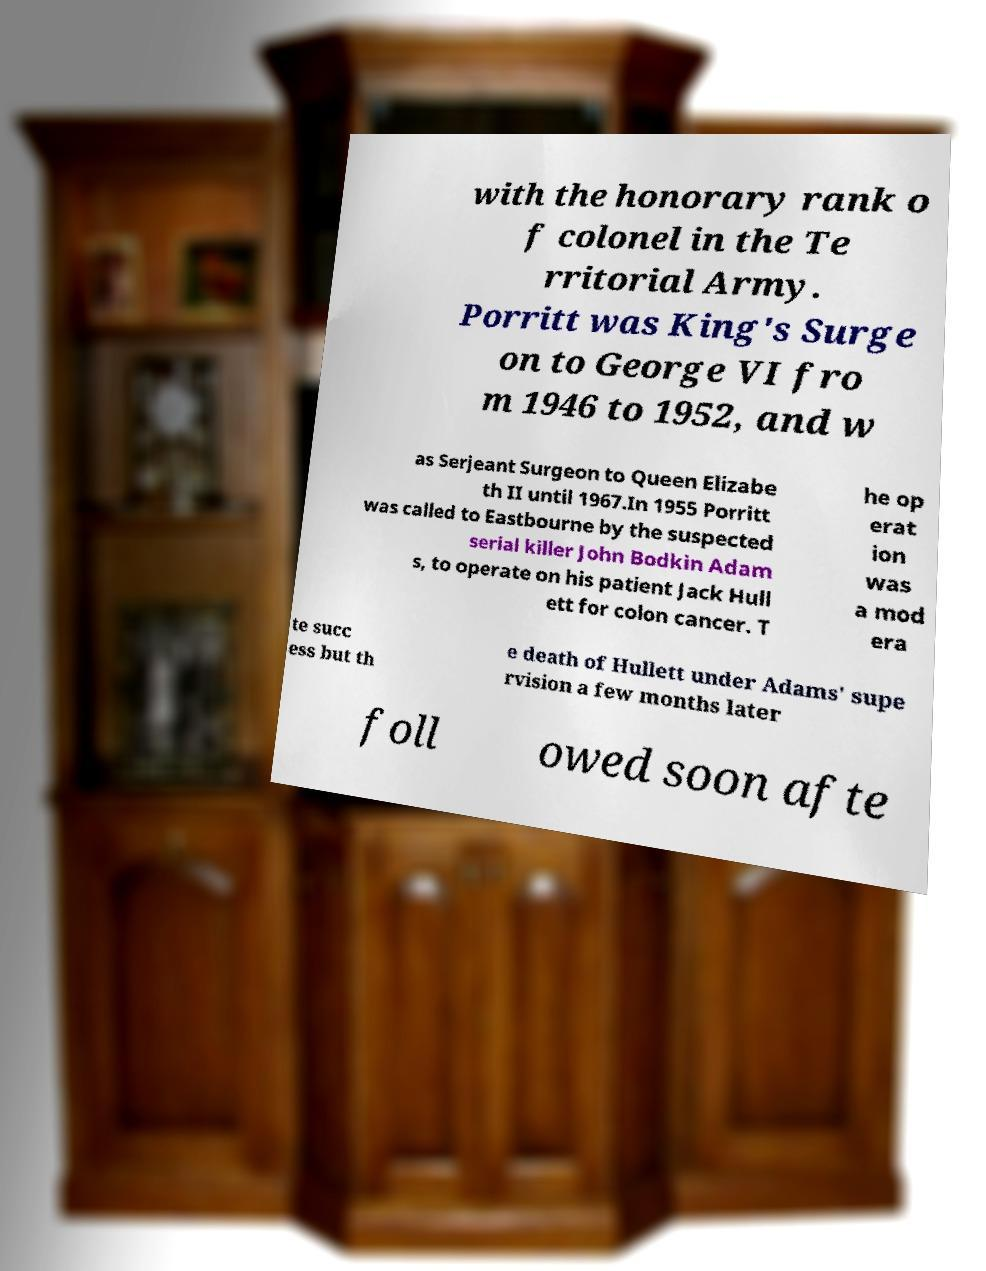Please identify and transcribe the text found in this image. with the honorary rank o f colonel in the Te rritorial Army. Porritt was King's Surge on to George VI fro m 1946 to 1952, and w as Serjeant Surgeon to Queen Elizabe th II until 1967.In 1955 Porritt was called to Eastbourne by the suspected serial killer John Bodkin Adam s, to operate on his patient Jack Hull ett for colon cancer. T he op erat ion was a mod era te succ ess but th e death of Hullett under Adams' supe rvision a few months later foll owed soon afte 